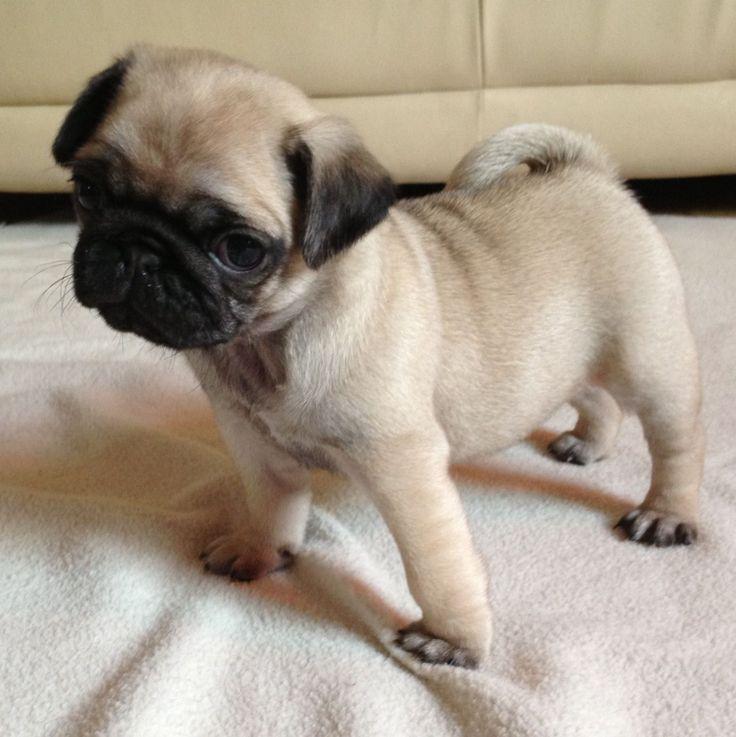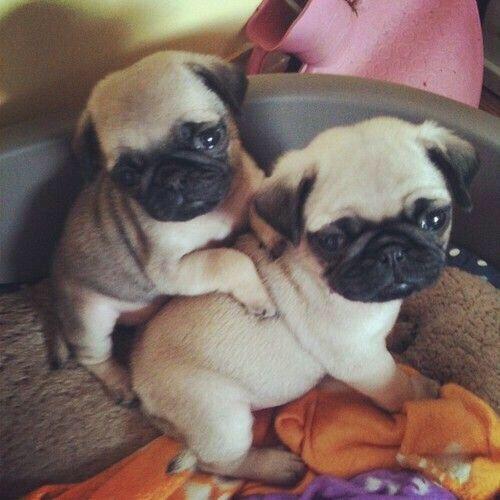The first image is the image on the left, the second image is the image on the right. Considering the images on both sides, is "The dog in the image on the left is on a pink piece of material." valid? Answer yes or no. No. The first image is the image on the left, the second image is the image on the right. Evaluate the accuracy of this statement regarding the images: "Each image contains exactly one small pug puppy, and the puppy on the left is in a sitting pose with its front paws on the ground.". Is it true? Answer yes or no. No. 